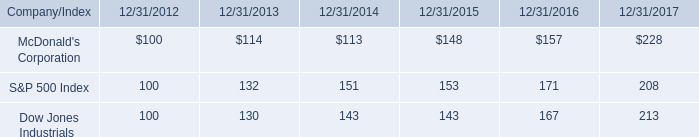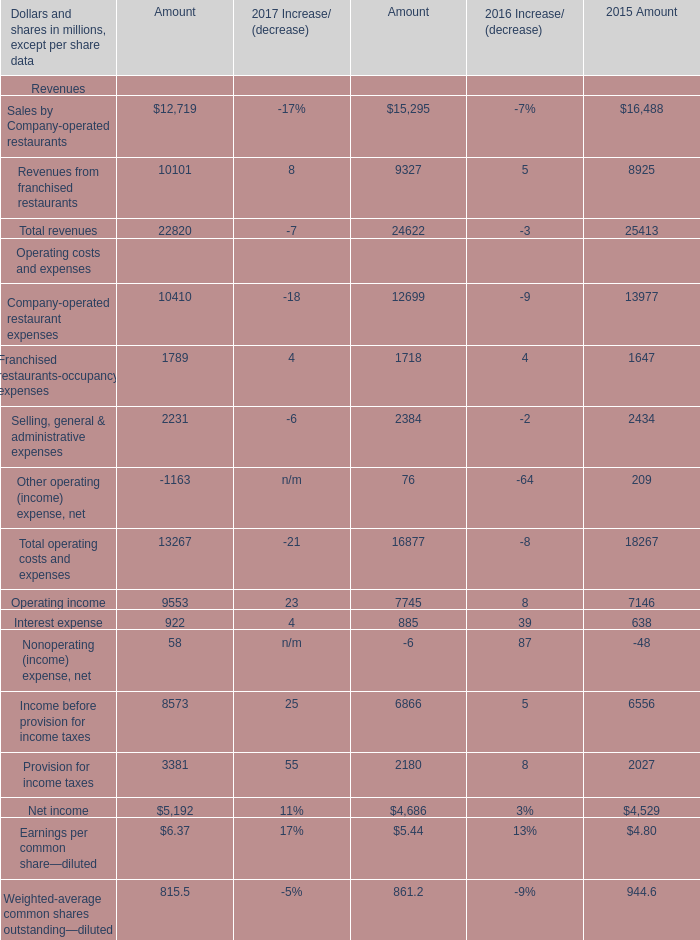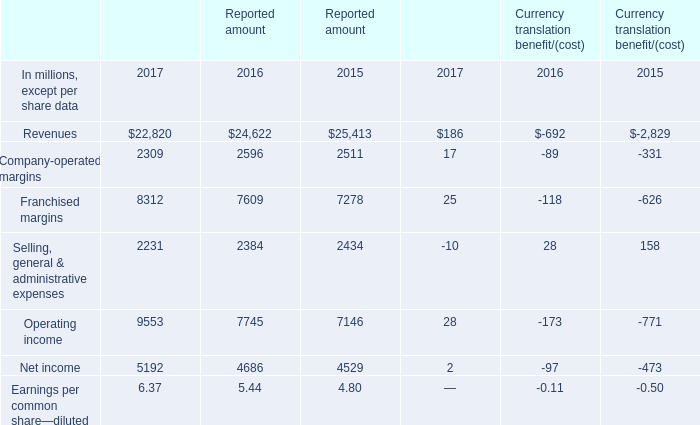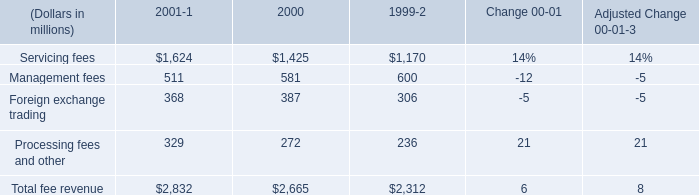what is the percent change of servicing fees between 1999 and 2000? 
Computations: ((1425 - 1170) / 1170)
Answer: 0.21795. 